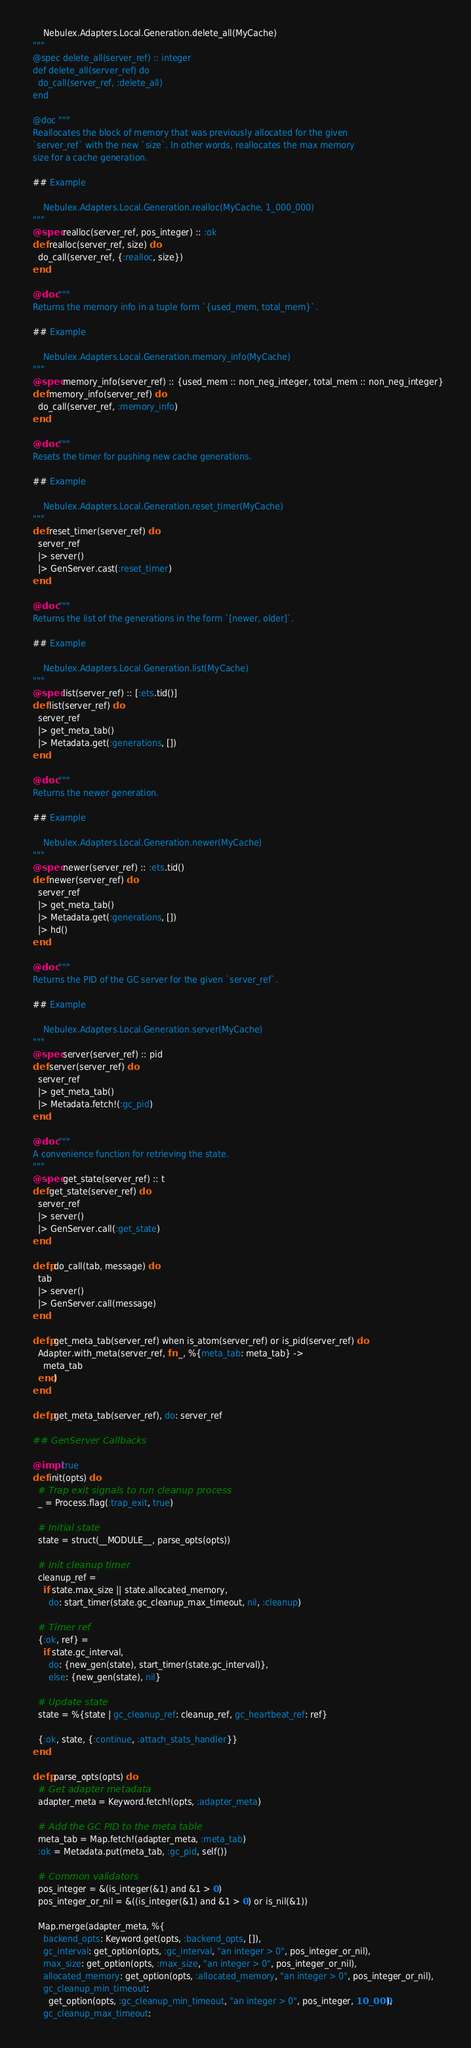Convert code to text. <code><loc_0><loc_0><loc_500><loc_500><_Elixir_>      Nebulex.Adapters.Local.Generation.delete_all(MyCache)
  """
  @spec delete_all(server_ref) :: integer
  def delete_all(server_ref) do
    do_call(server_ref, :delete_all)
  end

  @doc """
  Reallocates the block of memory that was previously allocated for the given
  `server_ref` with the new `size`. In other words, reallocates the max memory
  size for a cache generation.

  ## Example

      Nebulex.Adapters.Local.Generation.realloc(MyCache, 1_000_000)
  """
  @spec realloc(server_ref, pos_integer) :: :ok
  def realloc(server_ref, size) do
    do_call(server_ref, {:realloc, size})
  end

  @doc """
  Returns the memory info in a tuple form `{used_mem, total_mem}`.

  ## Example

      Nebulex.Adapters.Local.Generation.memory_info(MyCache)
  """
  @spec memory_info(server_ref) :: {used_mem :: non_neg_integer, total_mem :: non_neg_integer}
  def memory_info(server_ref) do
    do_call(server_ref, :memory_info)
  end

  @doc """
  Resets the timer for pushing new cache generations.

  ## Example

      Nebulex.Adapters.Local.Generation.reset_timer(MyCache)
  """
  def reset_timer(server_ref) do
    server_ref
    |> server()
    |> GenServer.cast(:reset_timer)
  end

  @doc """
  Returns the list of the generations in the form `[newer, older]`.

  ## Example

      Nebulex.Adapters.Local.Generation.list(MyCache)
  """
  @spec list(server_ref) :: [:ets.tid()]
  def list(server_ref) do
    server_ref
    |> get_meta_tab()
    |> Metadata.get(:generations, [])
  end

  @doc """
  Returns the newer generation.

  ## Example

      Nebulex.Adapters.Local.Generation.newer(MyCache)
  """
  @spec newer(server_ref) :: :ets.tid()
  def newer(server_ref) do
    server_ref
    |> get_meta_tab()
    |> Metadata.get(:generations, [])
    |> hd()
  end

  @doc """
  Returns the PID of the GC server for the given `server_ref`.

  ## Example

      Nebulex.Adapters.Local.Generation.server(MyCache)
  """
  @spec server(server_ref) :: pid
  def server(server_ref) do
    server_ref
    |> get_meta_tab()
    |> Metadata.fetch!(:gc_pid)
  end

  @doc """
  A convenience function for retrieving the state.
  """
  @spec get_state(server_ref) :: t
  def get_state(server_ref) do
    server_ref
    |> server()
    |> GenServer.call(:get_state)
  end

  defp do_call(tab, message) do
    tab
    |> server()
    |> GenServer.call(message)
  end

  defp get_meta_tab(server_ref) when is_atom(server_ref) or is_pid(server_ref) do
    Adapter.with_meta(server_ref, fn _, %{meta_tab: meta_tab} ->
      meta_tab
    end)
  end

  defp get_meta_tab(server_ref), do: server_ref

  ## GenServer Callbacks

  @impl true
  def init(opts) do
    # Trap exit signals to run cleanup process
    _ = Process.flag(:trap_exit, true)

    # Initial state
    state = struct(__MODULE__, parse_opts(opts))

    # Init cleanup timer
    cleanup_ref =
      if state.max_size || state.allocated_memory,
        do: start_timer(state.gc_cleanup_max_timeout, nil, :cleanup)

    # Timer ref
    {:ok, ref} =
      if state.gc_interval,
        do: {new_gen(state), start_timer(state.gc_interval)},
        else: {new_gen(state), nil}

    # Update state
    state = %{state | gc_cleanup_ref: cleanup_ref, gc_heartbeat_ref: ref}

    {:ok, state, {:continue, :attach_stats_handler}}
  end

  defp parse_opts(opts) do
    # Get adapter metadata
    adapter_meta = Keyword.fetch!(opts, :adapter_meta)

    # Add the GC PID to the meta table
    meta_tab = Map.fetch!(adapter_meta, :meta_tab)
    :ok = Metadata.put(meta_tab, :gc_pid, self())

    # Common validators
    pos_integer = &(is_integer(&1) and &1 > 0)
    pos_integer_or_nil = &((is_integer(&1) and &1 > 0) or is_nil(&1))

    Map.merge(adapter_meta, %{
      backend_opts: Keyword.get(opts, :backend_opts, []),
      gc_interval: get_option(opts, :gc_interval, "an integer > 0", pos_integer_or_nil),
      max_size: get_option(opts, :max_size, "an integer > 0", pos_integer_or_nil),
      allocated_memory: get_option(opts, :allocated_memory, "an integer > 0", pos_integer_or_nil),
      gc_cleanup_min_timeout:
        get_option(opts, :gc_cleanup_min_timeout, "an integer > 0", pos_integer, 10_000),
      gc_cleanup_max_timeout:</code> 